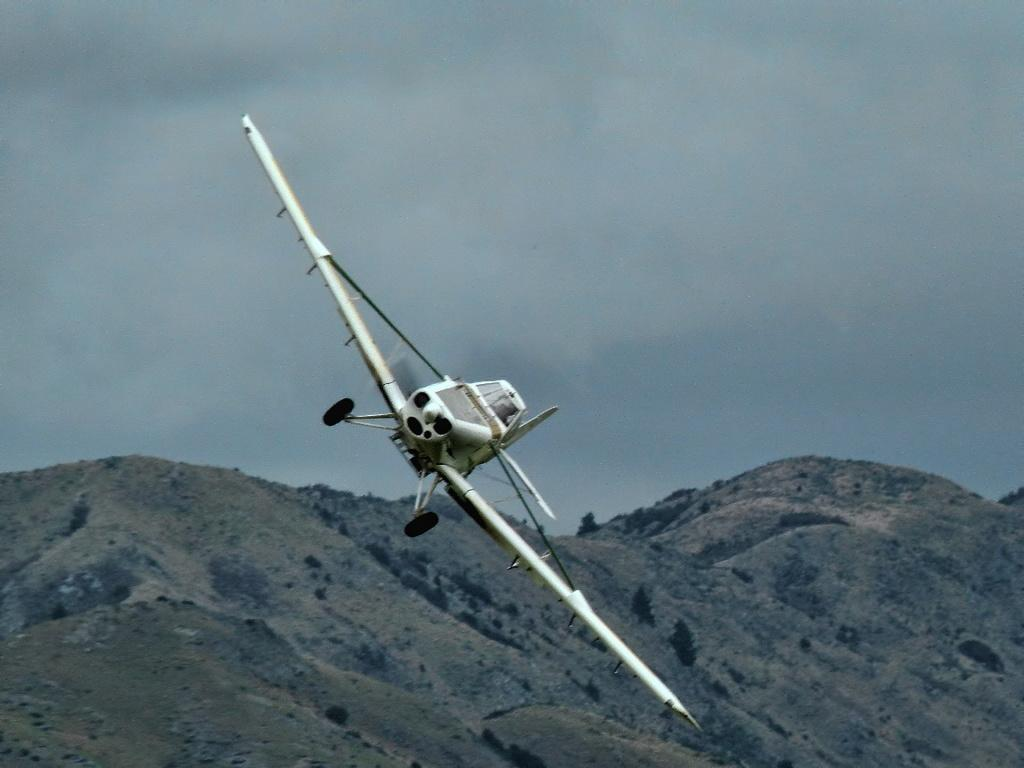What is the main subject of the image? The main subject of the image is an aircraft. What color is the aircraft? The aircraft is white in color. What can be seen in the background of the image? There are mountains visible in the background of the image. What is the color of the sky in the image? The sky is gray in color. Can you see a cave in the image? There is no cave present in the image; it features an aircraft and mountains in the background. What type of beetle can be seen crawling on the aircraft in the image? There are no beetles present in the image; it only features an aircraft and mountains in the background. 